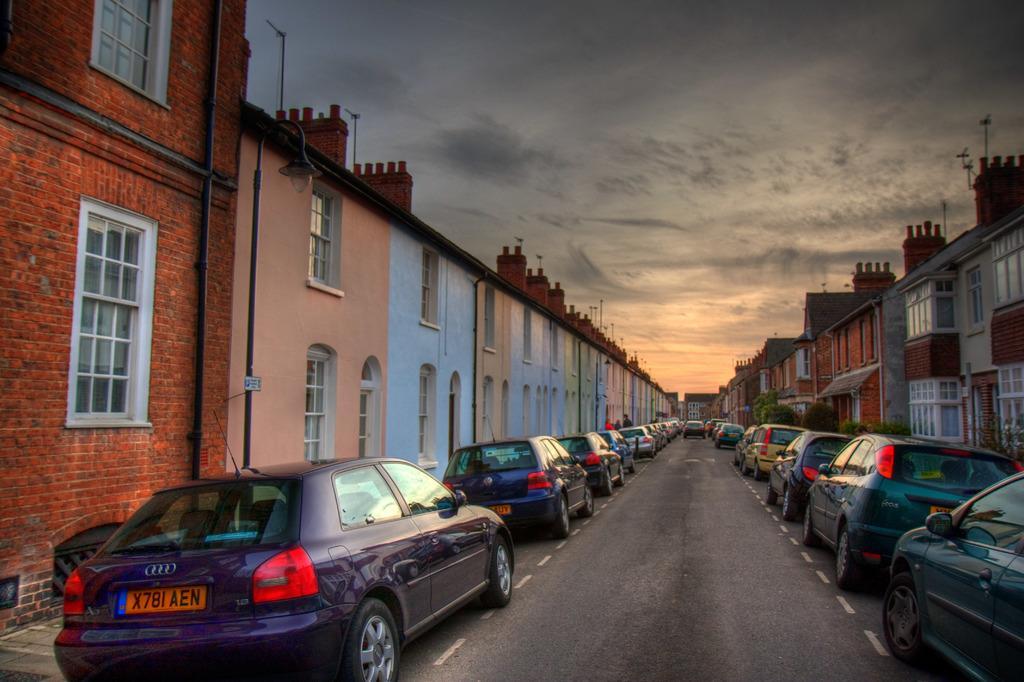Please provide a concise description of this image. In this image there are many cars parked on the road and there are buildings and poles on its sides. 